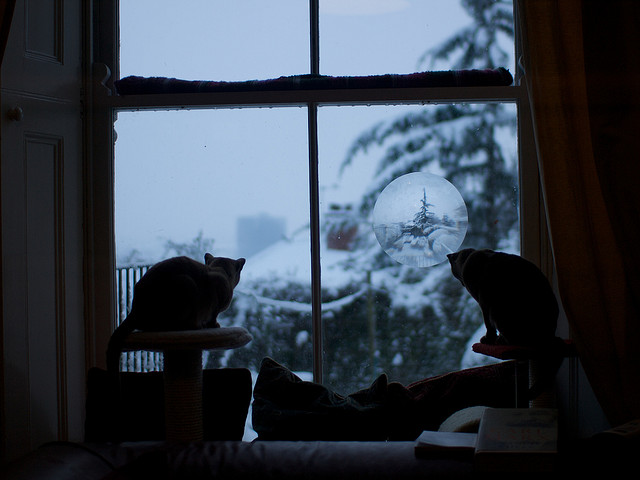<image>What kind of bird is looking through the window? There is no bird looking through the window. However, there might be an owl. What are the blurry birds doing? It is unknown what the blurry birds are doing. They could be perching, resting, sitting in a tree, or even flying. What kind of bird is looking through the window? There is no bird looking through the window. What are the blurry birds doing? I don't know what the blurry birds are doing. It is unclear based on the given options. 